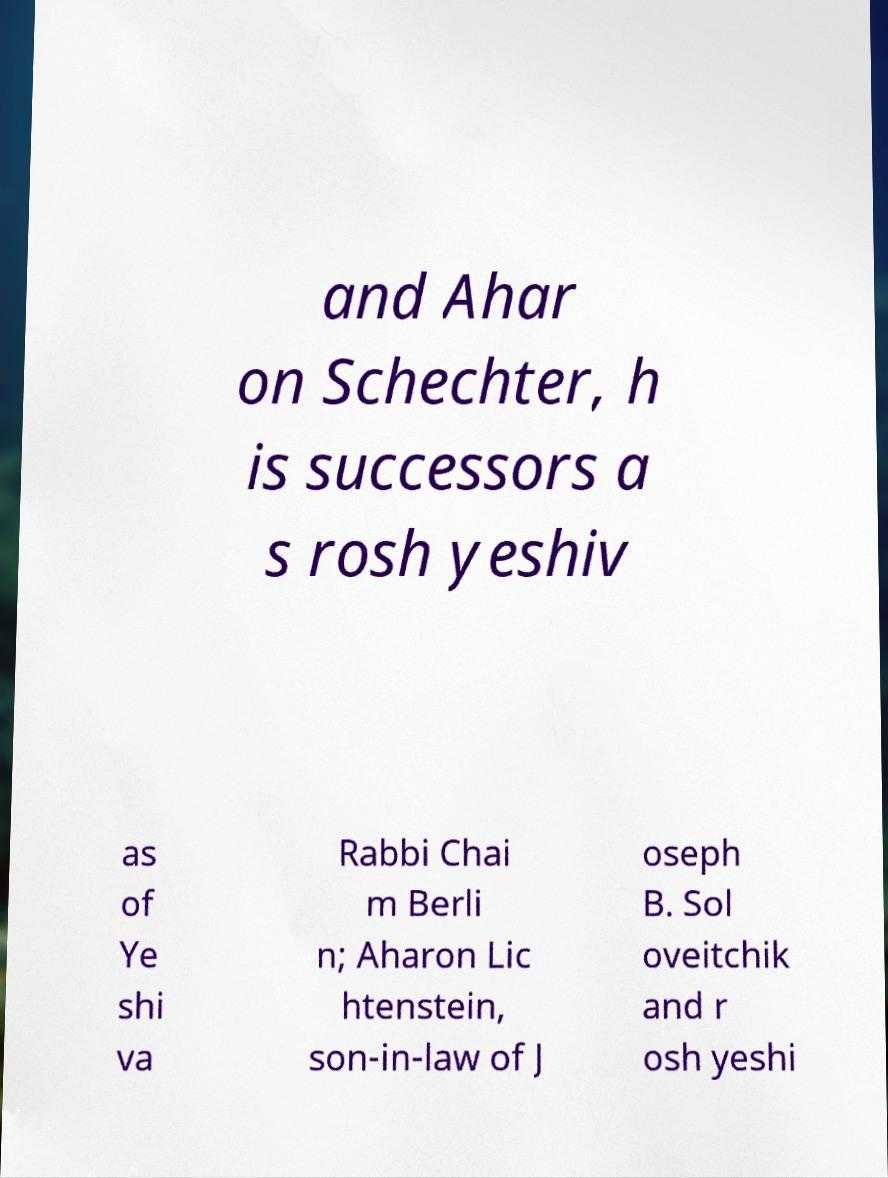Could you assist in decoding the text presented in this image and type it out clearly? and Ahar on Schechter, h is successors a s rosh yeshiv as of Ye shi va Rabbi Chai m Berli n; Aharon Lic htenstein, son-in-law of J oseph B. Sol oveitchik and r osh yeshi 